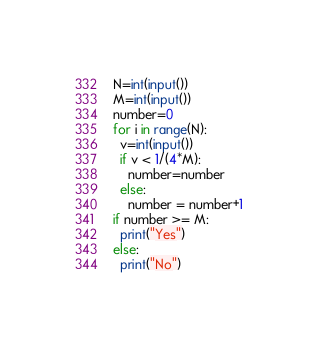<code> <loc_0><loc_0><loc_500><loc_500><_Python_>N=int(input())
M=int(input())
number=0
for i in range(N):
  v=int(input())
  if v < 1/(4*M):
    number=number
  else:
    number = number+1
if number >= M:
  print("Yes")
else:
  print("No")</code> 